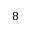Convert formula to latex. <formula><loc_0><loc_0><loc_500><loc_500>8</formula> 